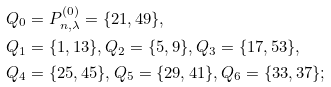Convert formula to latex. <formula><loc_0><loc_0><loc_500><loc_500>& Q _ { 0 } = P _ { n , \lambda } ^ { ( 0 ) } = \{ 2 1 , 4 9 \} , \\ & Q _ { 1 } = \{ 1 , 1 3 \} , Q _ { 2 } = \{ 5 , 9 \} , Q _ { 3 } = \{ 1 7 , 5 3 \} , \\ & Q _ { 4 } = \{ 2 5 , 4 5 \} , Q _ { 5 } = \{ 2 9 , 4 1 \} , Q _ { 6 } = \{ 3 3 , 3 7 \} ;</formula> 